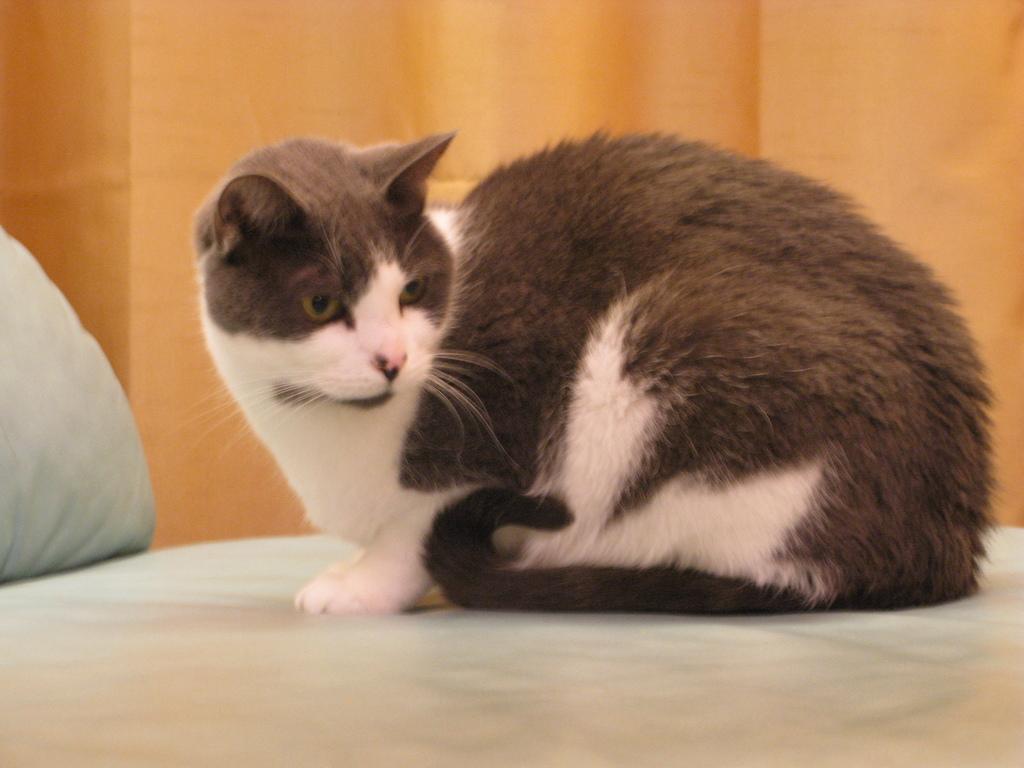Describe this image in one or two sentences. In this picture I see the couch which is of white color and I see a cat which is of white and brown color. In the background I see the orange color thing. 